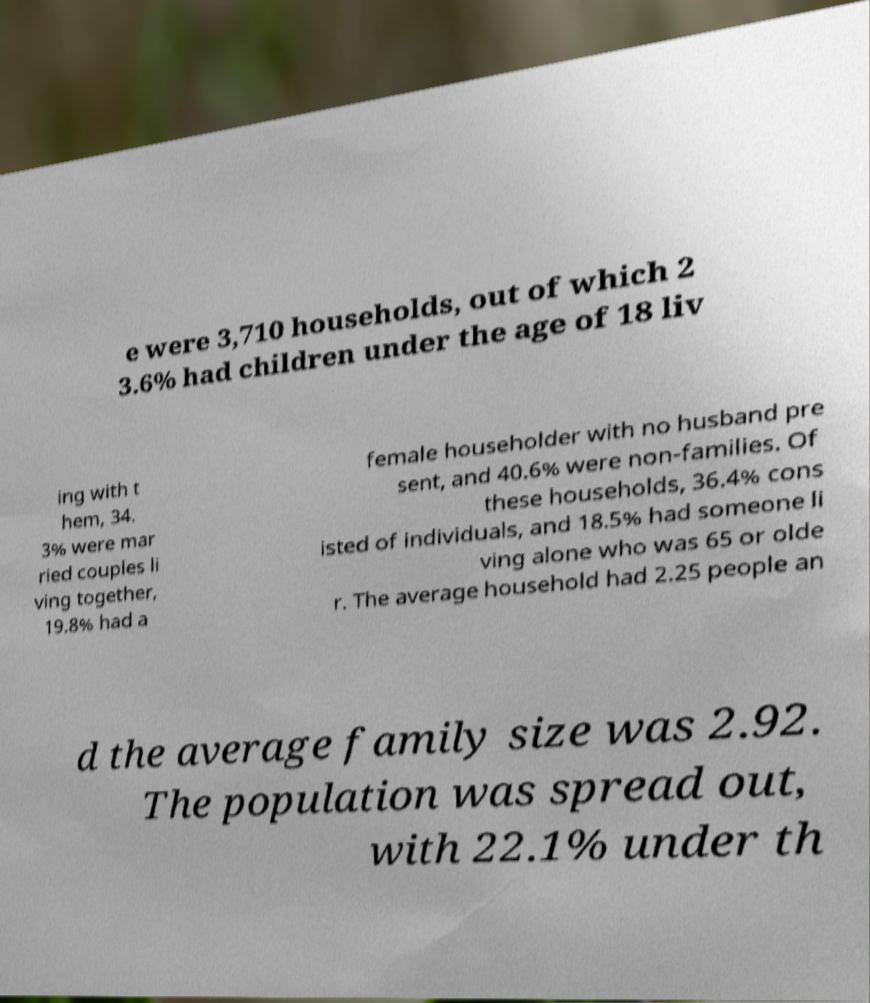For documentation purposes, I need the text within this image transcribed. Could you provide that? e were 3,710 households, out of which 2 3.6% had children under the age of 18 liv ing with t hem, 34. 3% were mar ried couples li ving together, 19.8% had a female householder with no husband pre sent, and 40.6% were non-families. Of these households, 36.4% cons isted of individuals, and 18.5% had someone li ving alone who was 65 or olde r. The average household had 2.25 people an d the average family size was 2.92. The population was spread out, with 22.1% under th 